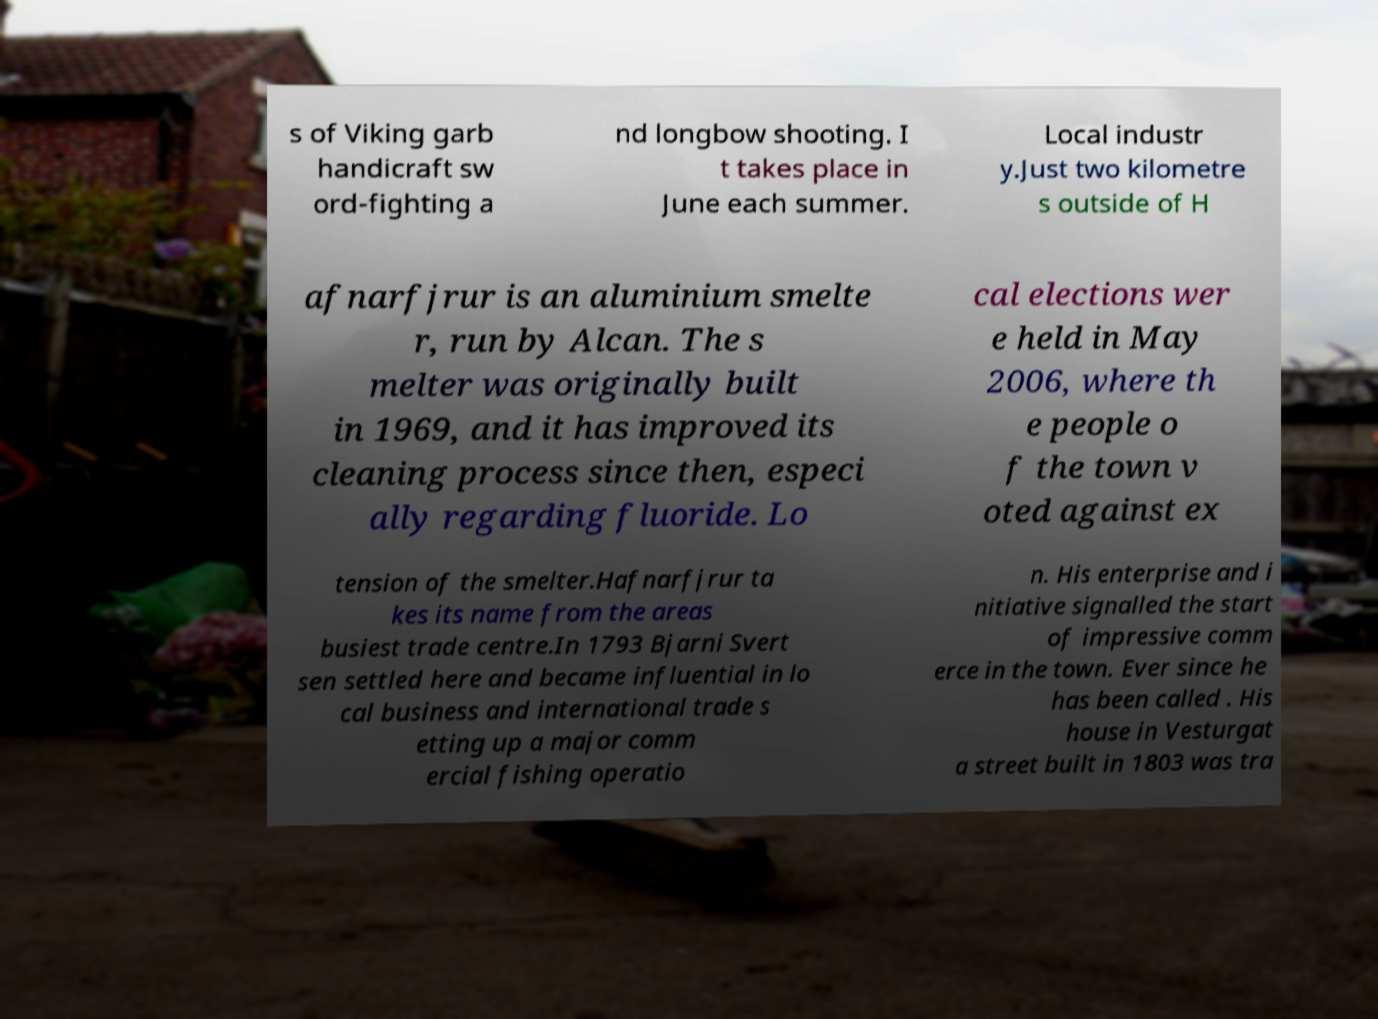Could you extract and type out the text from this image? s of Viking garb handicraft sw ord-fighting a nd longbow shooting. I t takes place in June each summer. Local industr y.Just two kilometre s outside of H afnarfjrur is an aluminium smelte r, run by Alcan. The s melter was originally built in 1969, and it has improved its cleaning process since then, especi ally regarding fluoride. Lo cal elections wer e held in May 2006, where th e people o f the town v oted against ex tension of the smelter.Hafnarfjrur ta kes its name from the areas busiest trade centre.In 1793 Bjarni Svert sen settled here and became influential in lo cal business and international trade s etting up a major comm ercial fishing operatio n. His enterprise and i nitiative signalled the start of impressive comm erce in the town. Ever since he has been called . His house in Vesturgat a street built in 1803 was tra 